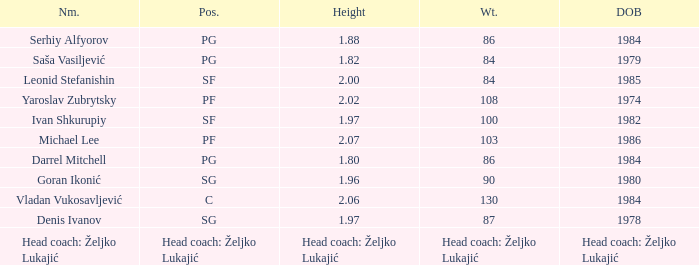What was the weight of Serhiy Alfyorov? 86.0. 